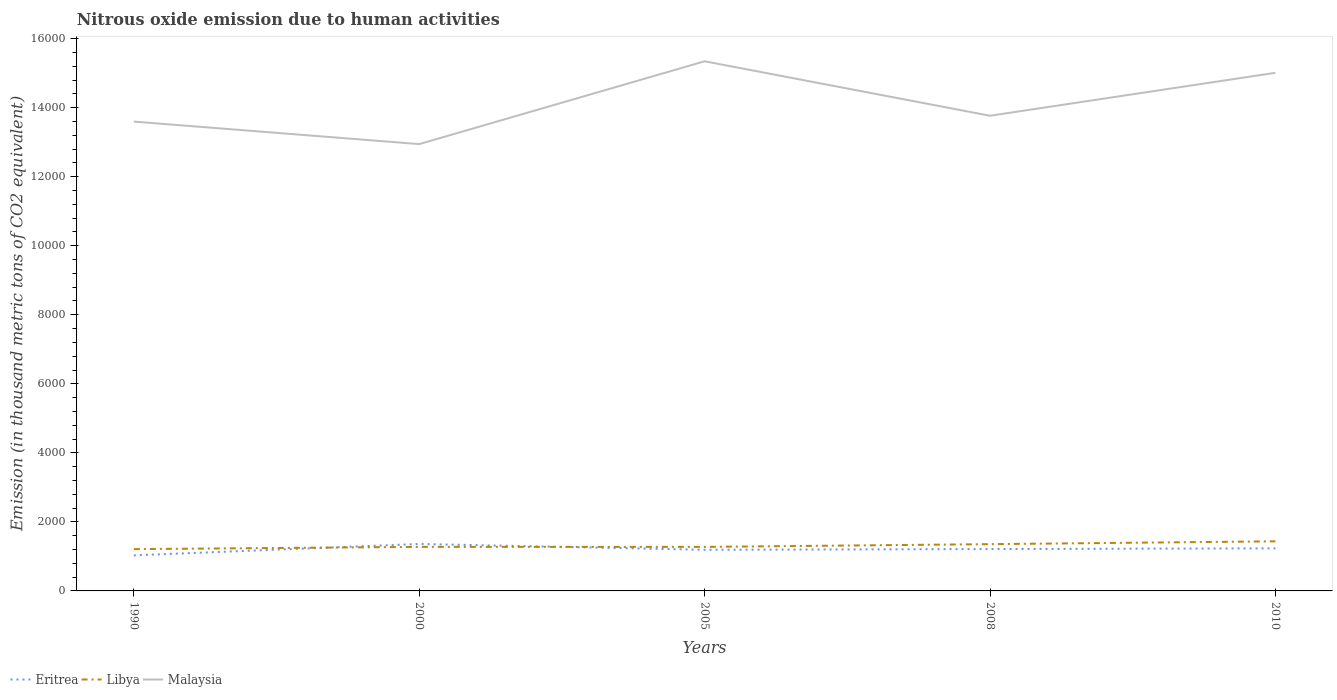How many different coloured lines are there?
Ensure brevity in your answer.  3. Across all years, what is the maximum amount of nitrous oxide emitted in Libya?
Provide a short and direct response. 1210.8. In which year was the amount of nitrous oxide emitted in Eritrea maximum?
Provide a short and direct response. 1990. What is the total amount of nitrous oxide emitted in Libya in the graph?
Give a very brief answer. -79.5. What is the difference between the highest and the second highest amount of nitrous oxide emitted in Libya?
Keep it short and to the point. 226.1. What is the difference between the highest and the lowest amount of nitrous oxide emitted in Malaysia?
Make the answer very short. 2. What is the difference between two consecutive major ticks on the Y-axis?
Give a very brief answer. 2000. Are the values on the major ticks of Y-axis written in scientific E-notation?
Keep it short and to the point. No. Does the graph contain any zero values?
Offer a terse response. No. Does the graph contain grids?
Provide a succinct answer. No. How are the legend labels stacked?
Offer a very short reply. Horizontal. What is the title of the graph?
Offer a terse response. Nitrous oxide emission due to human activities. Does "Greece" appear as one of the legend labels in the graph?
Make the answer very short. No. What is the label or title of the X-axis?
Offer a terse response. Years. What is the label or title of the Y-axis?
Provide a short and direct response. Emission (in thousand metric tons of CO2 equivalent). What is the Emission (in thousand metric tons of CO2 equivalent) in Eritrea in 1990?
Offer a terse response. 1030.6. What is the Emission (in thousand metric tons of CO2 equivalent) of Libya in 1990?
Offer a very short reply. 1210.8. What is the Emission (in thousand metric tons of CO2 equivalent) of Malaysia in 1990?
Your response must be concise. 1.36e+04. What is the Emission (in thousand metric tons of CO2 equivalent) of Eritrea in 2000?
Give a very brief answer. 1360.3. What is the Emission (in thousand metric tons of CO2 equivalent) in Libya in 2000?
Provide a succinct answer. 1276.1. What is the Emission (in thousand metric tons of CO2 equivalent) of Malaysia in 2000?
Your response must be concise. 1.29e+04. What is the Emission (in thousand metric tons of CO2 equivalent) of Eritrea in 2005?
Provide a succinct answer. 1191.7. What is the Emission (in thousand metric tons of CO2 equivalent) of Libya in 2005?
Your response must be concise. 1275.5. What is the Emission (in thousand metric tons of CO2 equivalent) of Malaysia in 2005?
Your answer should be compact. 1.53e+04. What is the Emission (in thousand metric tons of CO2 equivalent) in Eritrea in 2008?
Your answer should be compact. 1212.8. What is the Emission (in thousand metric tons of CO2 equivalent) of Libya in 2008?
Offer a very short reply. 1355. What is the Emission (in thousand metric tons of CO2 equivalent) of Malaysia in 2008?
Offer a terse response. 1.38e+04. What is the Emission (in thousand metric tons of CO2 equivalent) in Eritrea in 2010?
Your response must be concise. 1234. What is the Emission (in thousand metric tons of CO2 equivalent) of Libya in 2010?
Your answer should be very brief. 1436.9. What is the Emission (in thousand metric tons of CO2 equivalent) in Malaysia in 2010?
Ensure brevity in your answer.  1.50e+04. Across all years, what is the maximum Emission (in thousand metric tons of CO2 equivalent) of Eritrea?
Your answer should be compact. 1360.3. Across all years, what is the maximum Emission (in thousand metric tons of CO2 equivalent) in Libya?
Make the answer very short. 1436.9. Across all years, what is the maximum Emission (in thousand metric tons of CO2 equivalent) in Malaysia?
Ensure brevity in your answer.  1.53e+04. Across all years, what is the minimum Emission (in thousand metric tons of CO2 equivalent) in Eritrea?
Provide a short and direct response. 1030.6. Across all years, what is the minimum Emission (in thousand metric tons of CO2 equivalent) in Libya?
Your answer should be very brief. 1210.8. Across all years, what is the minimum Emission (in thousand metric tons of CO2 equivalent) in Malaysia?
Your answer should be compact. 1.29e+04. What is the total Emission (in thousand metric tons of CO2 equivalent) of Eritrea in the graph?
Provide a short and direct response. 6029.4. What is the total Emission (in thousand metric tons of CO2 equivalent) in Libya in the graph?
Give a very brief answer. 6554.3. What is the total Emission (in thousand metric tons of CO2 equivalent) of Malaysia in the graph?
Keep it short and to the point. 7.07e+04. What is the difference between the Emission (in thousand metric tons of CO2 equivalent) in Eritrea in 1990 and that in 2000?
Keep it short and to the point. -329.7. What is the difference between the Emission (in thousand metric tons of CO2 equivalent) of Libya in 1990 and that in 2000?
Provide a short and direct response. -65.3. What is the difference between the Emission (in thousand metric tons of CO2 equivalent) in Malaysia in 1990 and that in 2000?
Provide a short and direct response. 651.9. What is the difference between the Emission (in thousand metric tons of CO2 equivalent) in Eritrea in 1990 and that in 2005?
Ensure brevity in your answer.  -161.1. What is the difference between the Emission (in thousand metric tons of CO2 equivalent) in Libya in 1990 and that in 2005?
Provide a short and direct response. -64.7. What is the difference between the Emission (in thousand metric tons of CO2 equivalent) in Malaysia in 1990 and that in 2005?
Provide a succinct answer. -1747.4. What is the difference between the Emission (in thousand metric tons of CO2 equivalent) of Eritrea in 1990 and that in 2008?
Offer a terse response. -182.2. What is the difference between the Emission (in thousand metric tons of CO2 equivalent) in Libya in 1990 and that in 2008?
Your answer should be compact. -144.2. What is the difference between the Emission (in thousand metric tons of CO2 equivalent) of Malaysia in 1990 and that in 2008?
Offer a very short reply. -169.4. What is the difference between the Emission (in thousand metric tons of CO2 equivalent) of Eritrea in 1990 and that in 2010?
Your answer should be compact. -203.4. What is the difference between the Emission (in thousand metric tons of CO2 equivalent) of Libya in 1990 and that in 2010?
Offer a very short reply. -226.1. What is the difference between the Emission (in thousand metric tons of CO2 equivalent) in Malaysia in 1990 and that in 2010?
Your response must be concise. -1413.8. What is the difference between the Emission (in thousand metric tons of CO2 equivalent) in Eritrea in 2000 and that in 2005?
Your answer should be very brief. 168.6. What is the difference between the Emission (in thousand metric tons of CO2 equivalent) in Libya in 2000 and that in 2005?
Provide a succinct answer. 0.6. What is the difference between the Emission (in thousand metric tons of CO2 equivalent) in Malaysia in 2000 and that in 2005?
Give a very brief answer. -2399.3. What is the difference between the Emission (in thousand metric tons of CO2 equivalent) in Eritrea in 2000 and that in 2008?
Ensure brevity in your answer.  147.5. What is the difference between the Emission (in thousand metric tons of CO2 equivalent) in Libya in 2000 and that in 2008?
Provide a succinct answer. -78.9. What is the difference between the Emission (in thousand metric tons of CO2 equivalent) in Malaysia in 2000 and that in 2008?
Provide a short and direct response. -821.3. What is the difference between the Emission (in thousand metric tons of CO2 equivalent) of Eritrea in 2000 and that in 2010?
Give a very brief answer. 126.3. What is the difference between the Emission (in thousand metric tons of CO2 equivalent) of Libya in 2000 and that in 2010?
Your response must be concise. -160.8. What is the difference between the Emission (in thousand metric tons of CO2 equivalent) of Malaysia in 2000 and that in 2010?
Your answer should be compact. -2065.7. What is the difference between the Emission (in thousand metric tons of CO2 equivalent) in Eritrea in 2005 and that in 2008?
Keep it short and to the point. -21.1. What is the difference between the Emission (in thousand metric tons of CO2 equivalent) of Libya in 2005 and that in 2008?
Keep it short and to the point. -79.5. What is the difference between the Emission (in thousand metric tons of CO2 equivalent) in Malaysia in 2005 and that in 2008?
Offer a terse response. 1578. What is the difference between the Emission (in thousand metric tons of CO2 equivalent) of Eritrea in 2005 and that in 2010?
Provide a succinct answer. -42.3. What is the difference between the Emission (in thousand metric tons of CO2 equivalent) in Libya in 2005 and that in 2010?
Provide a short and direct response. -161.4. What is the difference between the Emission (in thousand metric tons of CO2 equivalent) of Malaysia in 2005 and that in 2010?
Give a very brief answer. 333.6. What is the difference between the Emission (in thousand metric tons of CO2 equivalent) in Eritrea in 2008 and that in 2010?
Offer a very short reply. -21.2. What is the difference between the Emission (in thousand metric tons of CO2 equivalent) in Libya in 2008 and that in 2010?
Your answer should be very brief. -81.9. What is the difference between the Emission (in thousand metric tons of CO2 equivalent) of Malaysia in 2008 and that in 2010?
Your answer should be compact. -1244.4. What is the difference between the Emission (in thousand metric tons of CO2 equivalent) in Eritrea in 1990 and the Emission (in thousand metric tons of CO2 equivalent) in Libya in 2000?
Offer a terse response. -245.5. What is the difference between the Emission (in thousand metric tons of CO2 equivalent) in Eritrea in 1990 and the Emission (in thousand metric tons of CO2 equivalent) in Malaysia in 2000?
Offer a very short reply. -1.19e+04. What is the difference between the Emission (in thousand metric tons of CO2 equivalent) of Libya in 1990 and the Emission (in thousand metric tons of CO2 equivalent) of Malaysia in 2000?
Your response must be concise. -1.17e+04. What is the difference between the Emission (in thousand metric tons of CO2 equivalent) in Eritrea in 1990 and the Emission (in thousand metric tons of CO2 equivalent) in Libya in 2005?
Ensure brevity in your answer.  -244.9. What is the difference between the Emission (in thousand metric tons of CO2 equivalent) of Eritrea in 1990 and the Emission (in thousand metric tons of CO2 equivalent) of Malaysia in 2005?
Your answer should be compact. -1.43e+04. What is the difference between the Emission (in thousand metric tons of CO2 equivalent) of Libya in 1990 and the Emission (in thousand metric tons of CO2 equivalent) of Malaysia in 2005?
Keep it short and to the point. -1.41e+04. What is the difference between the Emission (in thousand metric tons of CO2 equivalent) in Eritrea in 1990 and the Emission (in thousand metric tons of CO2 equivalent) in Libya in 2008?
Your response must be concise. -324.4. What is the difference between the Emission (in thousand metric tons of CO2 equivalent) in Eritrea in 1990 and the Emission (in thousand metric tons of CO2 equivalent) in Malaysia in 2008?
Provide a short and direct response. -1.27e+04. What is the difference between the Emission (in thousand metric tons of CO2 equivalent) in Libya in 1990 and the Emission (in thousand metric tons of CO2 equivalent) in Malaysia in 2008?
Your response must be concise. -1.26e+04. What is the difference between the Emission (in thousand metric tons of CO2 equivalent) in Eritrea in 1990 and the Emission (in thousand metric tons of CO2 equivalent) in Libya in 2010?
Your answer should be very brief. -406.3. What is the difference between the Emission (in thousand metric tons of CO2 equivalent) of Eritrea in 1990 and the Emission (in thousand metric tons of CO2 equivalent) of Malaysia in 2010?
Offer a terse response. -1.40e+04. What is the difference between the Emission (in thousand metric tons of CO2 equivalent) of Libya in 1990 and the Emission (in thousand metric tons of CO2 equivalent) of Malaysia in 2010?
Offer a terse response. -1.38e+04. What is the difference between the Emission (in thousand metric tons of CO2 equivalent) of Eritrea in 2000 and the Emission (in thousand metric tons of CO2 equivalent) of Libya in 2005?
Give a very brief answer. 84.8. What is the difference between the Emission (in thousand metric tons of CO2 equivalent) in Eritrea in 2000 and the Emission (in thousand metric tons of CO2 equivalent) in Malaysia in 2005?
Provide a succinct answer. -1.40e+04. What is the difference between the Emission (in thousand metric tons of CO2 equivalent) of Libya in 2000 and the Emission (in thousand metric tons of CO2 equivalent) of Malaysia in 2005?
Keep it short and to the point. -1.41e+04. What is the difference between the Emission (in thousand metric tons of CO2 equivalent) in Eritrea in 2000 and the Emission (in thousand metric tons of CO2 equivalent) in Libya in 2008?
Ensure brevity in your answer.  5.3. What is the difference between the Emission (in thousand metric tons of CO2 equivalent) of Eritrea in 2000 and the Emission (in thousand metric tons of CO2 equivalent) of Malaysia in 2008?
Your response must be concise. -1.24e+04. What is the difference between the Emission (in thousand metric tons of CO2 equivalent) of Libya in 2000 and the Emission (in thousand metric tons of CO2 equivalent) of Malaysia in 2008?
Give a very brief answer. -1.25e+04. What is the difference between the Emission (in thousand metric tons of CO2 equivalent) of Eritrea in 2000 and the Emission (in thousand metric tons of CO2 equivalent) of Libya in 2010?
Your answer should be compact. -76.6. What is the difference between the Emission (in thousand metric tons of CO2 equivalent) of Eritrea in 2000 and the Emission (in thousand metric tons of CO2 equivalent) of Malaysia in 2010?
Keep it short and to the point. -1.36e+04. What is the difference between the Emission (in thousand metric tons of CO2 equivalent) in Libya in 2000 and the Emission (in thousand metric tons of CO2 equivalent) in Malaysia in 2010?
Provide a short and direct response. -1.37e+04. What is the difference between the Emission (in thousand metric tons of CO2 equivalent) in Eritrea in 2005 and the Emission (in thousand metric tons of CO2 equivalent) in Libya in 2008?
Your response must be concise. -163.3. What is the difference between the Emission (in thousand metric tons of CO2 equivalent) of Eritrea in 2005 and the Emission (in thousand metric tons of CO2 equivalent) of Malaysia in 2008?
Make the answer very short. -1.26e+04. What is the difference between the Emission (in thousand metric tons of CO2 equivalent) in Libya in 2005 and the Emission (in thousand metric tons of CO2 equivalent) in Malaysia in 2008?
Keep it short and to the point. -1.25e+04. What is the difference between the Emission (in thousand metric tons of CO2 equivalent) of Eritrea in 2005 and the Emission (in thousand metric tons of CO2 equivalent) of Libya in 2010?
Give a very brief answer. -245.2. What is the difference between the Emission (in thousand metric tons of CO2 equivalent) in Eritrea in 2005 and the Emission (in thousand metric tons of CO2 equivalent) in Malaysia in 2010?
Provide a short and direct response. -1.38e+04. What is the difference between the Emission (in thousand metric tons of CO2 equivalent) of Libya in 2005 and the Emission (in thousand metric tons of CO2 equivalent) of Malaysia in 2010?
Provide a short and direct response. -1.37e+04. What is the difference between the Emission (in thousand metric tons of CO2 equivalent) in Eritrea in 2008 and the Emission (in thousand metric tons of CO2 equivalent) in Libya in 2010?
Ensure brevity in your answer.  -224.1. What is the difference between the Emission (in thousand metric tons of CO2 equivalent) of Eritrea in 2008 and the Emission (in thousand metric tons of CO2 equivalent) of Malaysia in 2010?
Offer a terse response. -1.38e+04. What is the difference between the Emission (in thousand metric tons of CO2 equivalent) of Libya in 2008 and the Emission (in thousand metric tons of CO2 equivalent) of Malaysia in 2010?
Keep it short and to the point. -1.37e+04. What is the average Emission (in thousand metric tons of CO2 equivalent) of Eritrea per year?
Your response must be concise. 1205.88. What is the average Emission (in thousand metric tons of CO2 equivalent) of Libya per year?
Keep it short and to the point. 1310.86. What is the average Emission (in thousand metric tons of CO2 equivalent) in Malaysia per year?
Ensure brevity in your answer.  1.41e+04. In the year 1990, what is the difference between the Emission (in thousand metric tons of CO2 equivalent) of Eritrea and Emission (in thousand metric tons of CO2 equivalent) of Libya?
Provide a succinct answer. -180.2. In the year 1990, what is the difference between the Emission (in thousand metric tons of CO2 equivalent) of Eritrea and Emission (in thousand metric tons of CO2 equivalent) of Malaysia?
Provide a short and direct response. -1.26e+04. In the year 1990, what is the difference between the Emission (in thousand metric tons of CO2 equivalent) in Libya and Emission (in thousand metric tons of CO2 equivalent) in Malaysia?
Your response must be concise. -1.24e+04. In the year 2000, what is the difference between the Emission (in thousand metric tons of CO2 equivalent) in Eritrea and Emission (in thousand metric tons of CO2 equivalent) in Libya?
Keep it short and to the point. 84.2. In the year 2000, what is the difference between the Emission (in thousand metric tons of CO2 equivalent) in Eritrea and Emission (in thousand metric tons of CO2 equivalent) in Malaysia?
Offer a very short reply. -1.16e+04. In the year 2000, what is the difference between the Emission (in thousand metric tons of CO2 equivalent) in Libya and Emission (in thousand metric tons of CO2 equivalent) in Malaysia?
Provide a short and direct response. -1.17e+04. In the year 2005, what is the difference between the Emission (in thousand metric tons of CO2 equivalent) of Eritrea and Emission (in thousand metric tons of CO2 equivalent) of Libya?
Ensure brevity in your answer.  -83.8. In the year 2005, what is the difference between the Emission (in thousand metric tons of CO2 equivalent) in Eritrea and Emission (in thousand metric tons of CO2 equivalent) in Malaysia?
Give a very brief answer. -1.42e+04. In the year 2005, what is the difference between the Emission (in thousand metric tons of CO2 equivalent) of Libya and Emission (in thousand metric tons of CO2 equivalent) of Malaysia?
Give a very brief answer. -1.41e+04. In the year 2008, what is the difference between the Emission (in thousand metric tons of CO2 equivalent) in Eritrea and Emission (in thousand metric tons of CO2 equivalent) in Libya?
Give a very brief answer. -142.2. In the year 2008, what is the difference between the Emission (in thousand metric tons of CO2 equivalent) of Eritrea and Emission (in thousand metric tons of CO2 equivalent) of Malaysia?
Keep it short and to the point. -1.26e+04. In the year 2008, what is the difference between the Emission (in thousand metric tons of CO2 equivalent) in Libya and Emission (in thousand metric tons of CO2 equivalent) in Malaysia?
Ensure brevity in your answer.  -1.24e+04. In the year 2010, what is the difference between the Emission (in thousand metric tons of CO2 equivalent) of Eritrea and Emission (in thousand metric tons of CO2 equivalent) of Libya?
Provide a succinct answer. -202.9. In the year 2010, what is the difference between the Emission (in thousand metric tons of CO2 equivalent) of Eritrea and Emission (in thousand metric tons of CO2 equivalent) of Malaysia?
Your answer should be very brief. -1.38e+04. In the year 2010, what is the difference between the Emission (in thousand metric tons of CO2 equivalent) of Libya and Emission (in thousand metric tons of CO2 equivalent) of Malaysia?
Give a very brief answer. -1.36e+04. What is the ratio of the Emission (in thousand metric tons of CO2 equivalent) in Eritrea in 1990 to that in 2000?
Give a very brief answer. 0.76. What is the ratio of the Emission (in thousand metric tons of CO2 equivalent) of Libya in 1990 to that in 2000?
Make the answer very short. 0.95. What is the ratio of the Emission (in thousand metric tons of CO2 equivalent) in Malaysia in 1990 to that in 2000?
Provide a short and direct response. 1.05. What is the ratio of the Emission (in thousand metric tons of CO2 equivalent) in Eritrea in 1990 to that in 2005?
Ensure brevity in your answer.  0.86. What is the ratio of the Emission (in thousand metric tons of CO2 equivalent) in Libya in 1990 to that in 2005?
Your answer should be compact. 0.95. What is the ratio of the Emission (in thousand metric tons of CO2 equivalent) of Malaysia in 1990 to that in 2005?
Provide a succinct answer. 0.89. What is the ratio of the Emission (in thousand metric tons of CO2 equivalent) of Eritrea in 1990 to that in 2008?
Your answer should be compact. 0.85. What is the ratio of the Emission (in thousand metric tons of CO2 equivalent) of Libya in 1990 to that in 2008?
Give a very brief answer. 0.89. What is the ratio of the Emission (in thousand metric tons of CO2 equivalent) in Eritrea in 1990 to that in 2010?
Offer a very short reply. 0.84. What is the ratio of the Emission (in thousand metric tons of CO2 equivalent) in Libya in 1990 to that in 2010?
Your response must be concise. 0.84. What is the ratio of the Emission (in thousand metric tons of CO2 equivalent) of Malaysia in 1990 to that in 2010?
Make the answer very short. 0.91. What is the ratio of the Emission (in thousand metric tons of CO2 equivalent) of Eritrea in 2000 to that in 2005?
Provide a short and direct response. 1.14. What is the ratio of the Emission (in thousand metric tons of CO2 equivalent) in Malaysia in 2000 to that in 2005?
Give a very brief answer. 0.84. What is the ratio of the Emission (in thousand metric tons of CO2 equivalent) in Eritrea in 2000 to that in 2008?
Keep it short and to the point. 1.12. What is the ratio of the Emission (in thousand metric tons of CO2 equivalent) in Libya in 2000 to that in 2008?
Ensure brevity in your answer.  0.94. What is the ratio of the Emission (in thousand metric tons of CO2 equivalent) of Malaysia in 2000 to that in 2008?
Keep it short and to the point. 0.94. What is the ratio of the Emission (in thousand metric tons of CO2 equivalent) in Eritrea in 2000 to that in 2010?
Provide a short and direct response. 1.1. What is the ratio of the Emission (in thousand metric tons of CO2 equivalent) of Libya in 2000 to that in 2010?
Provide a short and direct response. 0.89. What is the ratio of the Emission (in thousand metric tons of CO2 equivalent) in Malaysia in 2000 to that in 2010?
Your response must be concise. 0.86. What is the ratio of the Emission (in thousand metric tons of CO2 equivalent) of Eritrea in 2005 to that in 2008?
Your answer should be very brief. 0.98. What is the ratio of the Emission (in thousand metric tons of CO2 equivalent) of Libya in 2005 to that in 2008?
Make the answer very short. 0.94. What is the ratio of the Emission (in thousand metric tons of CO2 equivalent) of Malaysia in 2005 to that in 2008?
Make the answer very short. 1.11. What is the ratio of the Emission (in thousand metric tons of CO2 equivalent) of Eritrea in 2005 to that in 2010?
Your answer should be very brief. 0.97. What is the ratio of the Emission (in thousand metric tons of CO2 equivalent) of Libya in 2005 to that in 2010?
Ensure brevity in your answer.  0.89. What is the ratio of the Emission (in thousand metric tons of CO2 equivalent) of Malaysia in 2005 to that in 2010?
Your response must be concise. 1.02. What is the ratio of the Emission (in thousand metric tons of CO2 equivalent) in Eritrea in 2008 to that in 2010?
Make the answer very short. 0.98. What is the ratio of the Emission (in thousand metric tons of CO2 equivalent) in Libya in 2008 to that in 2010?
Ensure brevity in your answer.  0.94. What is the ratio of the Emission (in thousand metric tons of CO2 equivalent) of Malaysia in 2008 to that in 2010?
Make the answer very short. 0.92. What is the difference between the highest and the second highest Emission (in thousand metric tons of CO2 equivalent) of Eritrea?
Your answer should be very brief. 126.3. What is the difference between the highest and the second highest Emission (in thousand metric tons of CO2 equivalent) in Libya?
Your answer should be very brief. 81.9. What is the difference between the highest and the second highest Emission (in thousand metric tons of CO2 equivalent) of Malaysia?
Keep it short and to the point. 333.6. What is the difference between the highest and the lowest Emission (in thousand metric tons of CO2 equivalent) of Eritrea?
Your response must be concise. 329.7. What is the difference between the highest and the lowest Emission (in thousand metric tons of CO2 equivalent) of Libya?
Provide a short and direct response. 226.1. What is the difference between the highest and the lowest Emission (in thousand metric tons of CO2 equivalent) of Malaysia?
Provide a short and direct response. 2399.3. 